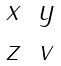<formula> <loc_0><loc_0><loc_500><loc_500>\begin{matrix} x & y \\ z & v \end{matrix}</formula> 